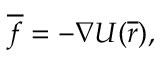<formula> <loc_0><loc_0><loc_500><loc_500>{ \overline { f } } = - { \nabla U } ( { \overline { r } } ) ,</formula> 